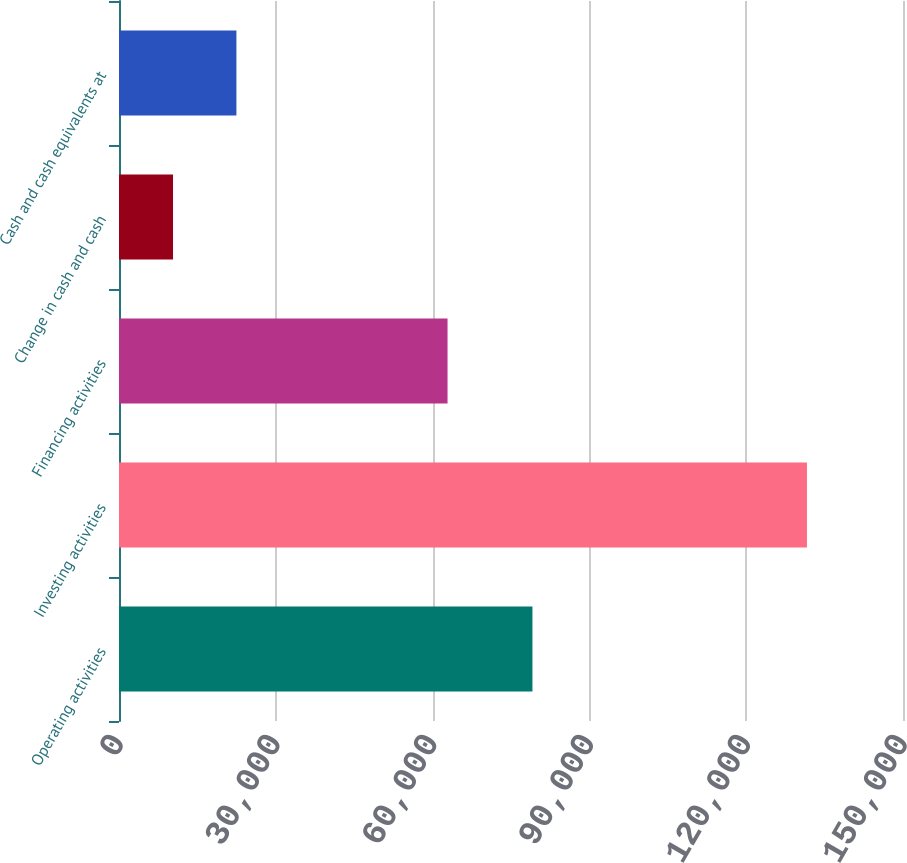Convert chart. <chart><loc_0><loc_0><loc_500><loc_500><bar_chart><fcel>Operating activities<fcel>Investing activities<fcel>Financing activities<fcel>Change in cash and cash<fcel>Cash and cash equivalents at<nl><fcel>79101<fcel>131623<fcel>62858<fcel>10336<fcel>22464.7<nl></chart> 